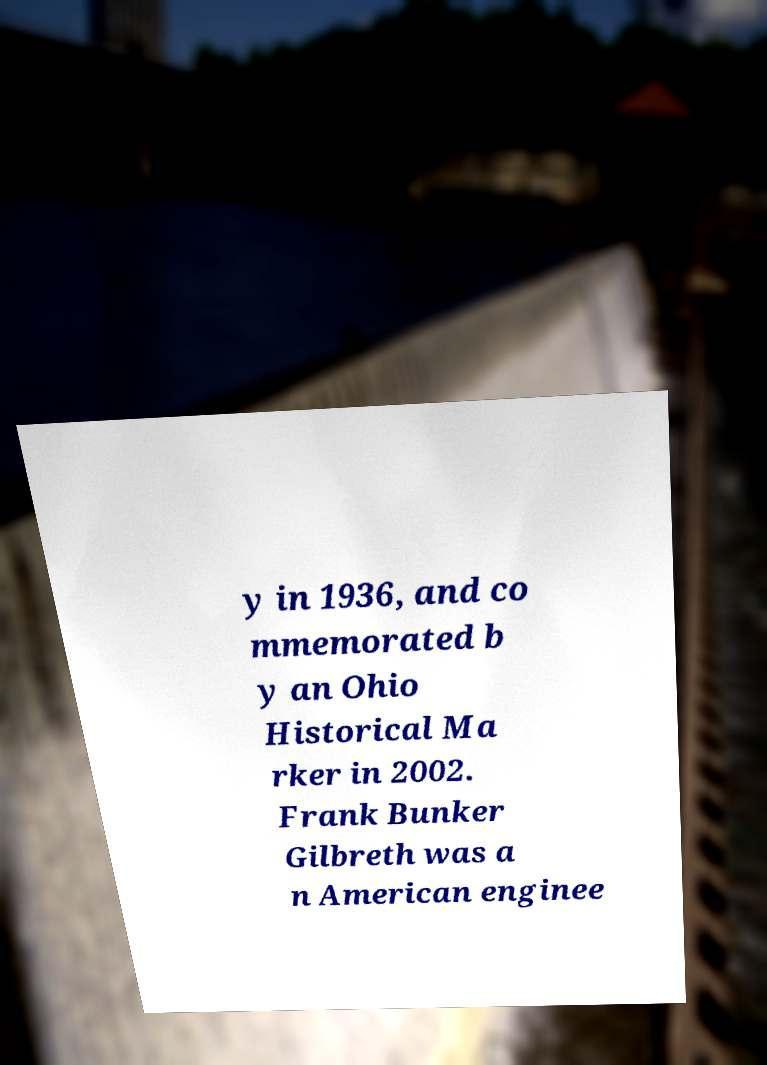For documentation purposes, I need the text within this image transcribed. Could you provide that? y in 1936, and co mmemorated b y an Ohio Historical Ma rker in 2002. Frank Bunker Gilbreth was a n American enginee 